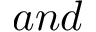<formula> <loc_0><loc_0><loc_500><loc_500>a n d</formula> 